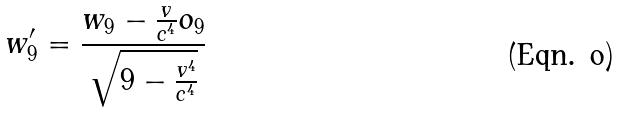Convert formula to latex. <formula><loc_0><loc_0><loc_500><loc_500>w _ { 9 } ^ { \prime } = \frac { w _ { 9 } - \frac { v } { c ^ { 4 } } o _ { 9 } } { \sqrt { 9 - \frac { v ^ { 4 } } { c ^ { 4 } } } }</formula> 